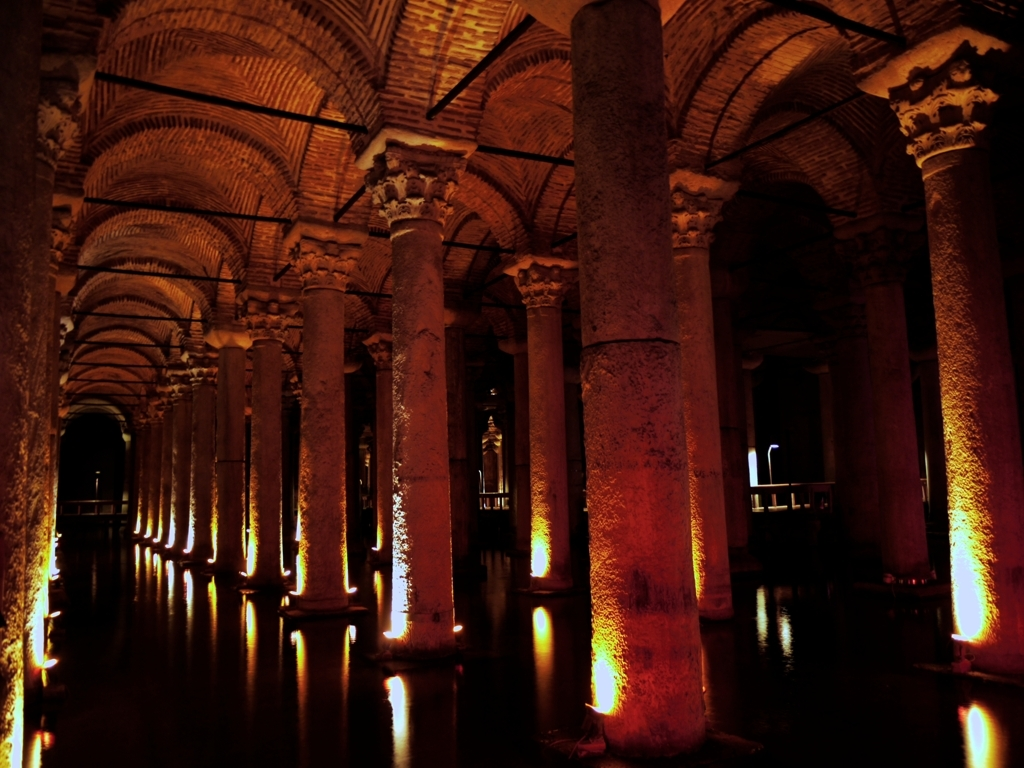Can you tell me more about the architectural style shown here? Certainly, the image shows a series of columns supporting a vaulted ceiling, which are characteristic of Roman and Byzantine architecture. The repetition of arches and pillars creates a rhythmic pattern that is both functional and aesthetically pleasing. 